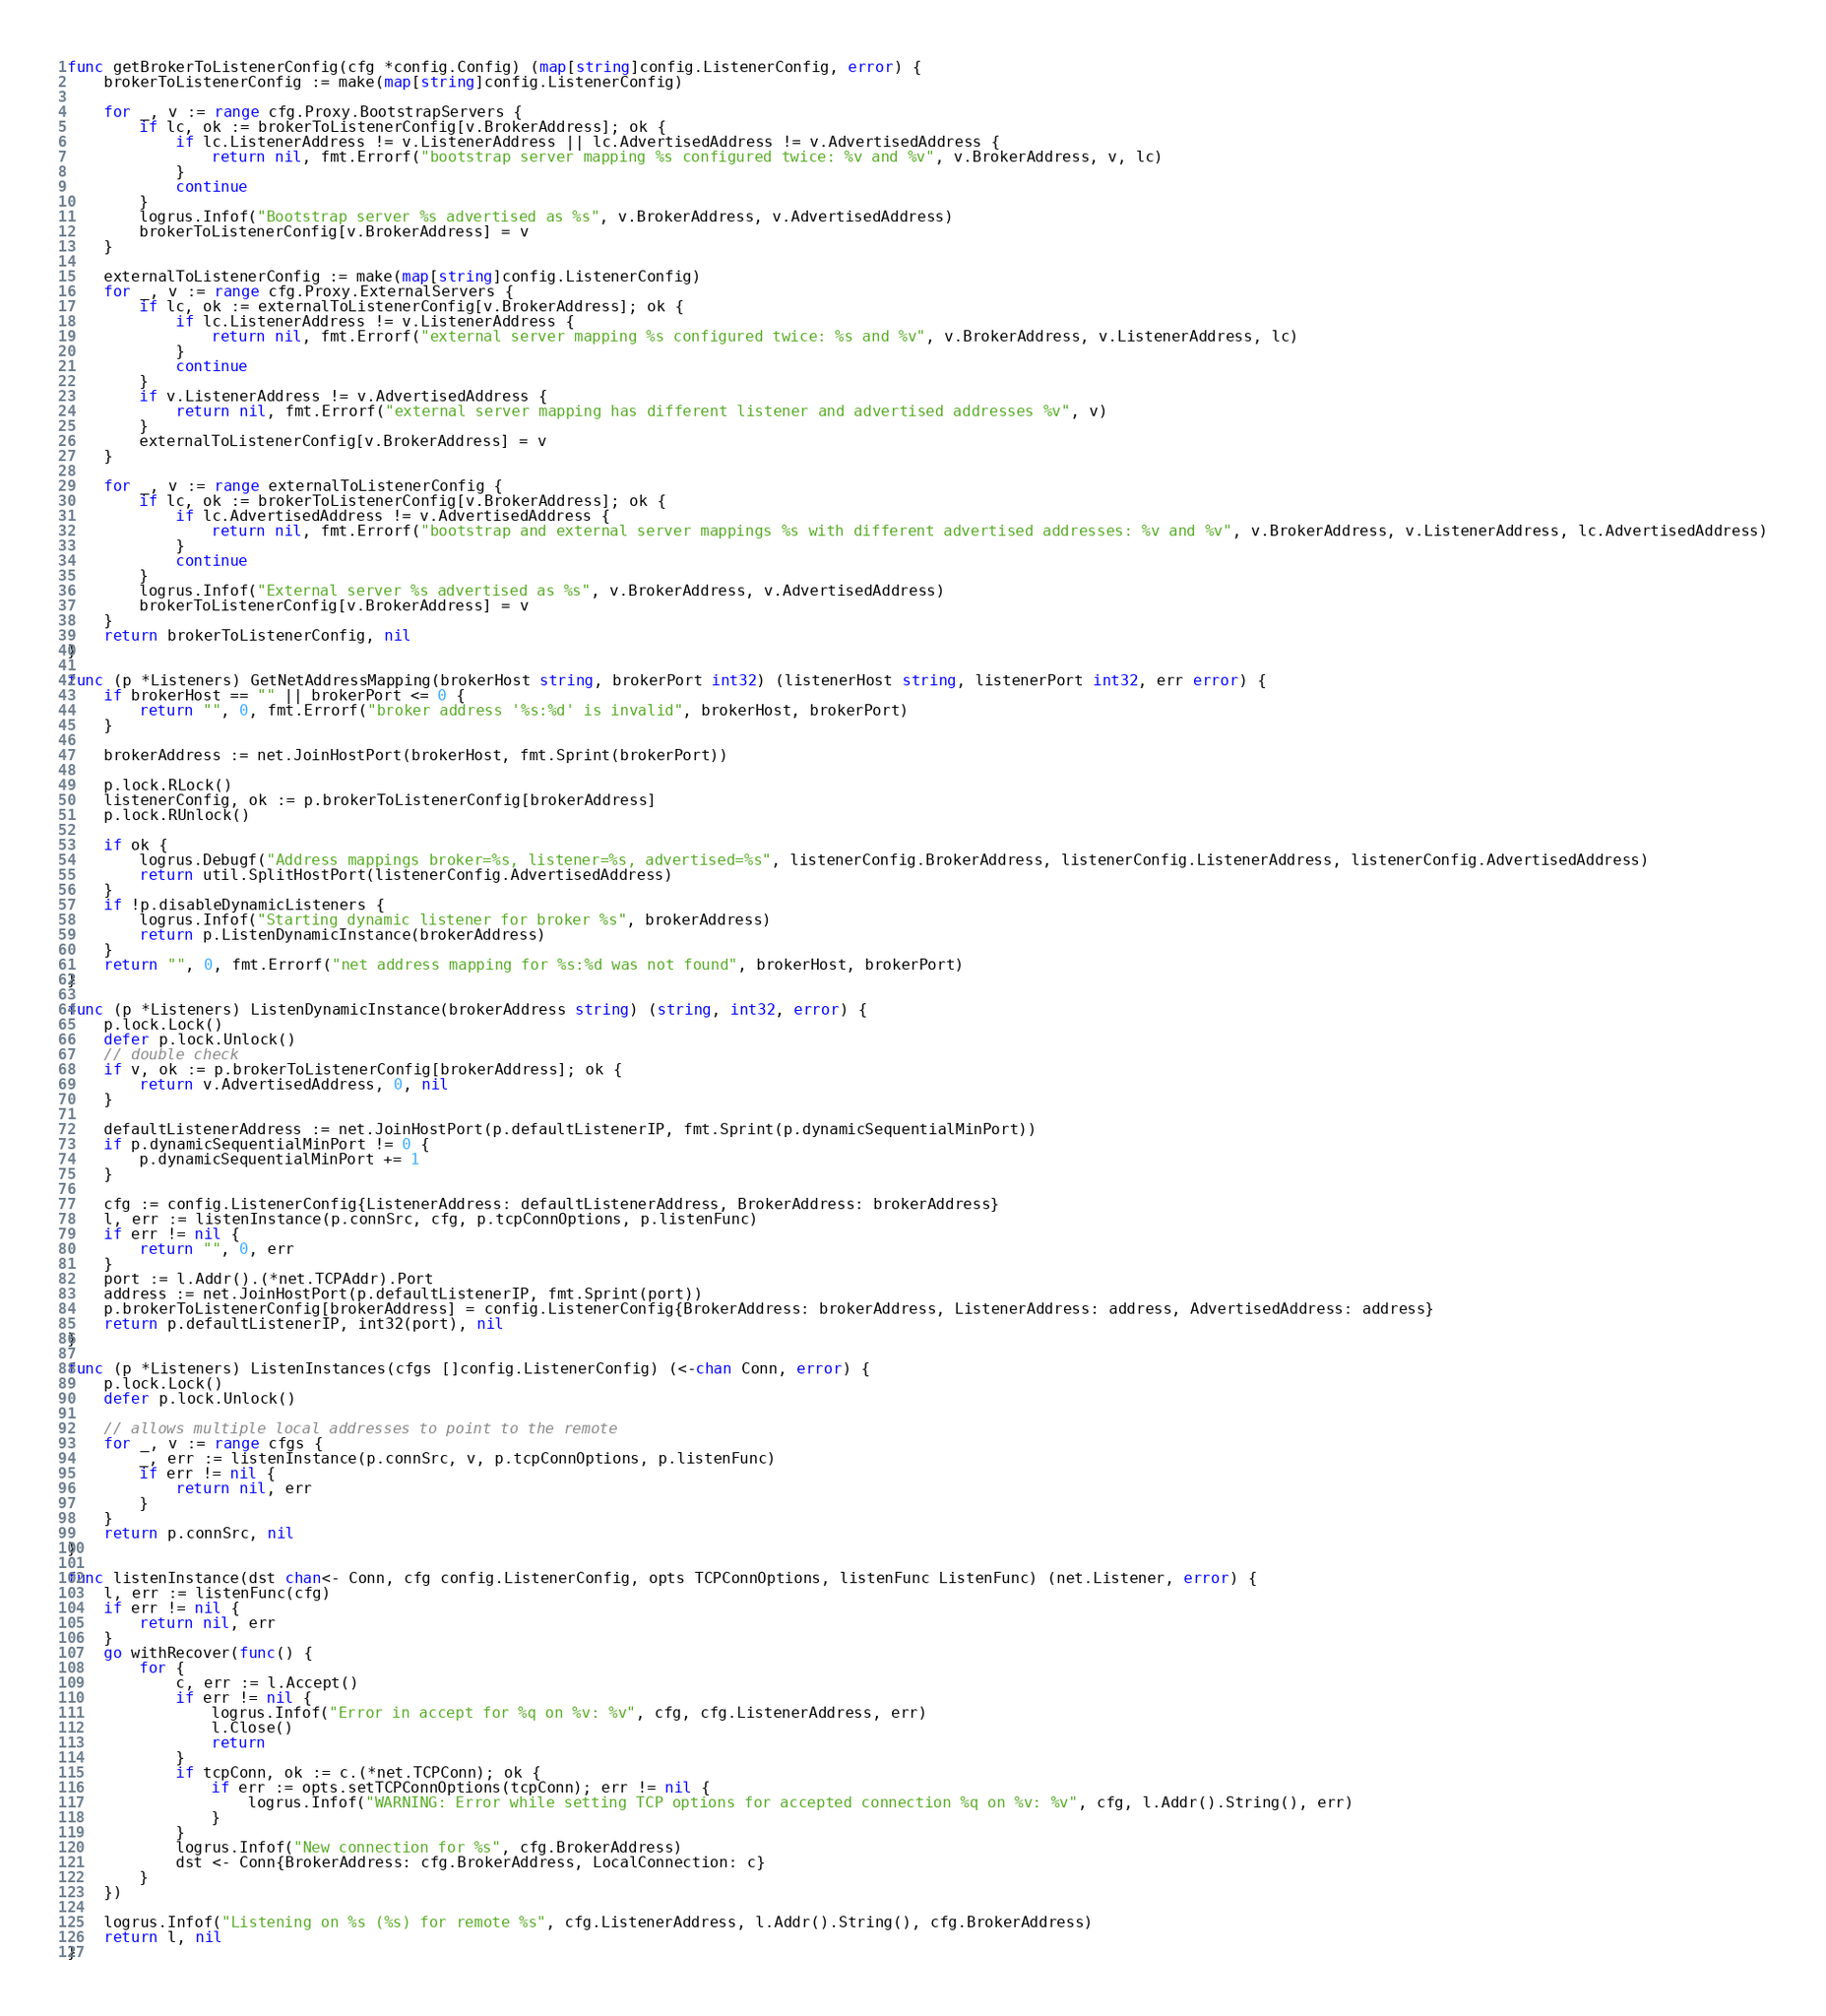Convert code to text. <code><loc_0><loc_0><loc_500><loc_500><_Go_>
func getBrokerToListenerConfig(cfg *config.Config) (map[string]config.ListenerConfig, error) {
	brokerToListenerConfig := make(map[string]config.ListenerConfig)

	for _, v := range cfg.Proxy.BootstrapServers {
		if lc, ok := brokerToListenerConfig[v.BrokerAddress]; ok {
			if lc.ListenerAddress != v.ListenerAddress || lc.AdvertisedAddress != v.AdvertisedAddress {
				return nil, fmt.Errorf("bootstrap server mapping %s configured twice: %v and %v", v.BrokerAddress, v, lc)
			}
			continue
		}
		logrus.Infof("Bootstrap server %s advertised as %s", v.BrokerAddress, v.AdvertisedAddress)
		brokerToListenerConfig[v.BrokerAddress] = v
	}

	externalToListenerConfig := make(map[string]config.ListenerConfig)
	for _, v := range cfg.Proxy.ExternalServers {
		if lc, ok := externalToListenerConfig[v.BrokerAddress]; ok {
			if lc.ListenerAddress != v.ListenerAddress {
				return nil, fmt.Errorf("external server mapping %s configured twice: %s and %v", v.BrokerAddress, v.ListenerAddress, lc)
			}
			continue
		}
		if v.ListenerAddress != v.AdvertisedAddress {
			return nil, fmt.Errorf("external server mapping has different listener and advertised addresses %v", v)
		}
		externalToListenerConfig[v.BrokerAddress] = v
	}

	for _, v := range externalToListenerConfig {
		if lc, ok := brokerToListenerConfig[v.BrokerAddress]; ok {
			if lc.AdvertisedAddress != v.AdvertisedAddress {
				return nil, fmt.Errorf("bootstrap and external server mappings %s with different advertised addresses: %v and %v", v.BrokerAddress, v.ListenerAddress, lc.AdvertisedAddress)
			}
			continue
		}
		logrus.Infof("External server %s advertised as %s", v.BrokerAddress, v.AdvertisedAddress)
		brokerToListenerConfig[v.BrokerAddress] = v
	}
	return brokerToListenerConfig, nil
}

func (p *Listeners) GetNetAddressMapping(brokerHost string, brokerPort int32) (listenerHost string, listenerPort int32, err error) {
	if brokerHost == "" || brokerPort <= 0 {
		return "", 0, fmt.Errorf("broker address '%s:%d' is invalid", brokerHost, brokerPort)
	}

	brokerAddress := net.JoinHostPort(brokerHost, fmt.Sprint(brokerPort))

	p.lock.RLock()
	listenerConfig, ok := p.brokerToListenerConfig[brokerAddress]
	p.lock.RUnlock()

	if ok {
		logrus.Debugf("Address mappings broker=%s, listener=%s, advertised=%s", listenerConfig.BrokerAddress, listenerConfig.ListenerAddress, listenerConfig.AdvertisedAddress)
		return util.SplitHostPort(listenerConfig.AdvertisedAddress)
	}
	if !p.disableDynamicListeners {
		logrus.Infof("Starting dynamic listener for broker %s", brokerAddress)
		return p.ListenDynamicInstance(brokerAddress)
	}
	return "", 0, fmt.Errorf("net address mapping for %s:%d was not found", brokerHost, brokerPort)
}

func (p *Listeners) ListenDynamicInstance(brokerAddress string) (string, int32, error) {
	p.lock.Lock()
	defer p.lock.Unlock()
	// double check
	if v, ok := p.brokerToListenerConfig[brokerAddress]; ok {
		return v.AdvertisedAddress, 0, nil
	}

	defaultListenerAddress := net.JoinHostPort(p.defaultListenerIP, fmt.Sprint(p.dynamicSequentialMinPort))
	if p.dynamicSequentialMinPort != 0 {
		p.dynamicSequentialMinPort += 1
	}

	cfg := config.ListenerConfig{ListenerAddress: defaultListenerAddress, BrokerAddress: brokerAddress}
	l, err := listenInstance(p.connSrc, cfg, p.tcpConnOptions, p.listenFunc)
	if err != nil {
		return "", 0, err
	}
	port := l.Addr().(*net.TCPAddr).Port
	address := net.JoinHostPort(p.defaultListenerIP, fmt.Sprint(port))
	p.brokerToListenerConfig[brokerAddress] = config.ListenerConfig{BrokerAddress: brokerAddress, ListenerAddress: address, AdvertisedAddress: address}
	return p.defaultListenerIP, int32(port), nil
}

func (p *Listeners) ListenInstances(cfgs []config.ListenerConfig) (<-chan Conn, error) {
	p.lock.Lock()
	defer p.lock.Unlock()

	// allows multiple local addresses to point to the remote
	for _, v := range cfgs {
		_, err := listenInstance(p.connSrc, v, p.tcpConnOptions, p.listenFunc)
		if err != nil {
			return nil, err
		}
	}
	return p.connSrc, nil
}

func listenInstance(dst chan<- Conn, cfg config.ListenerConfig, opts TCPConnOptions, listenFunc ListenFunc) (net.Listener, error) {
	l, err := listenFunc(cfg)
	if err != nil {
		return nil, err
	}
	go withRecover(func() {
		for {
			c, err := l.Accept()
			if err != nil {
				logrus.Infof("Error in accept for %q on %v: %v", cfg, cfg.ListenerAddress, err)
				l.Close()
				return
			}
			if tcpConn, ok := c.(*net.TCPConn); ok {
				if err := opts.setTCPConnOptions(tcpConn); err != nil {
					logrus.Infof("WARNING: Error while setting TCP options for accepted connection %q on %v: %v", cfg, l.Addr().String(), err)
				}
			}
			logrus.Infof("New connection for %s", cfg.BrokerAddress)
			dst <- Conn{BrokerAddress: cfg.BrokerAddress, LocalConnection: c}
		}
	})

	logrus.Infof("Listening on %s (%s) for remote %s", cfg.ListenerAddress, l.Addr().String(), cfg.BrokerAddress)
	return l, nil
}
</code> 